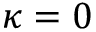<formula> <loc_0><loc_0><loc_500><loc_500>\kappa = 0</formula> 